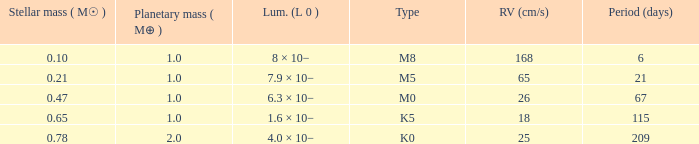What is the shortest time frame (days) to hold a planetary mass of 1, a stellar mass larger than 67.0. 